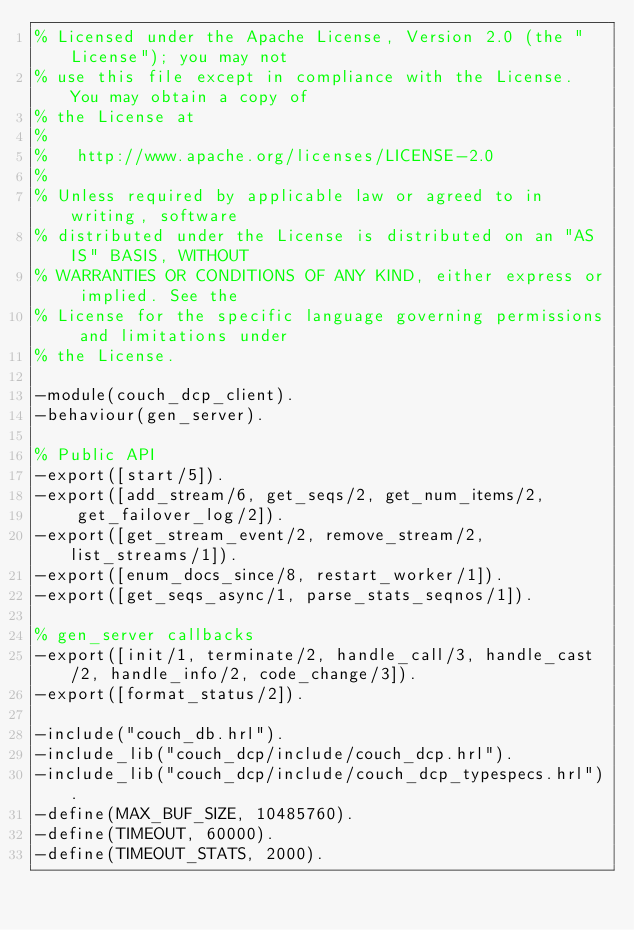<code> <loc_0><loc_0><loc_500><loc_500><_Erlang_>% Licensed under the Apache License, Version 2.0 (the "License"); you may not
% use this file except in compliance with the License. You may obtain a copy of
% the License at
%
%   http://www.apache.org/licenses/LICENSE-2.0
%
% Unless required by applicable law or agreed to in writing, software
% distributed under the License is distributed on an "AS IS" BASIS, WITHOUT
% WARRANTIES OR CONDITIONS OF ANY KIND, either express or implied. See the
% License for the specific language governing permissions and limitations under
% the License.

-module(couch_dcp_client).
-behaviour(gen_server).

% Public API
-export([start/5]).
-export([add_stream/6, get_seqs/2, get_num_items/2,
    get_failover_log/2]).
-export([get_stream_event/2, remove_stream/2, list_streams/1]).
-export([enum_docs_since/8, restart_worker/1]).
-export([get_seqs_async/1, parse_stats_seqnos/1]).

% gen_server callbacks
-export([init/1, terminate/2, handle_call/3, handle_cast/2, handle_info/2, code_change/3]).
-export([format_status/2]).

-include("couch_db.hrl").
-include_lib("couch_dcp/include/couch_dcp.hrl").
-include_lib("couch_dcp/include/couch_dcp_typespecs.hrl").
-define(MAX_BUF_SIZE, 10485760).
-define(TIMEOUT, 60000).
-define(TIMEOUT_STATS, 2000).</code> 